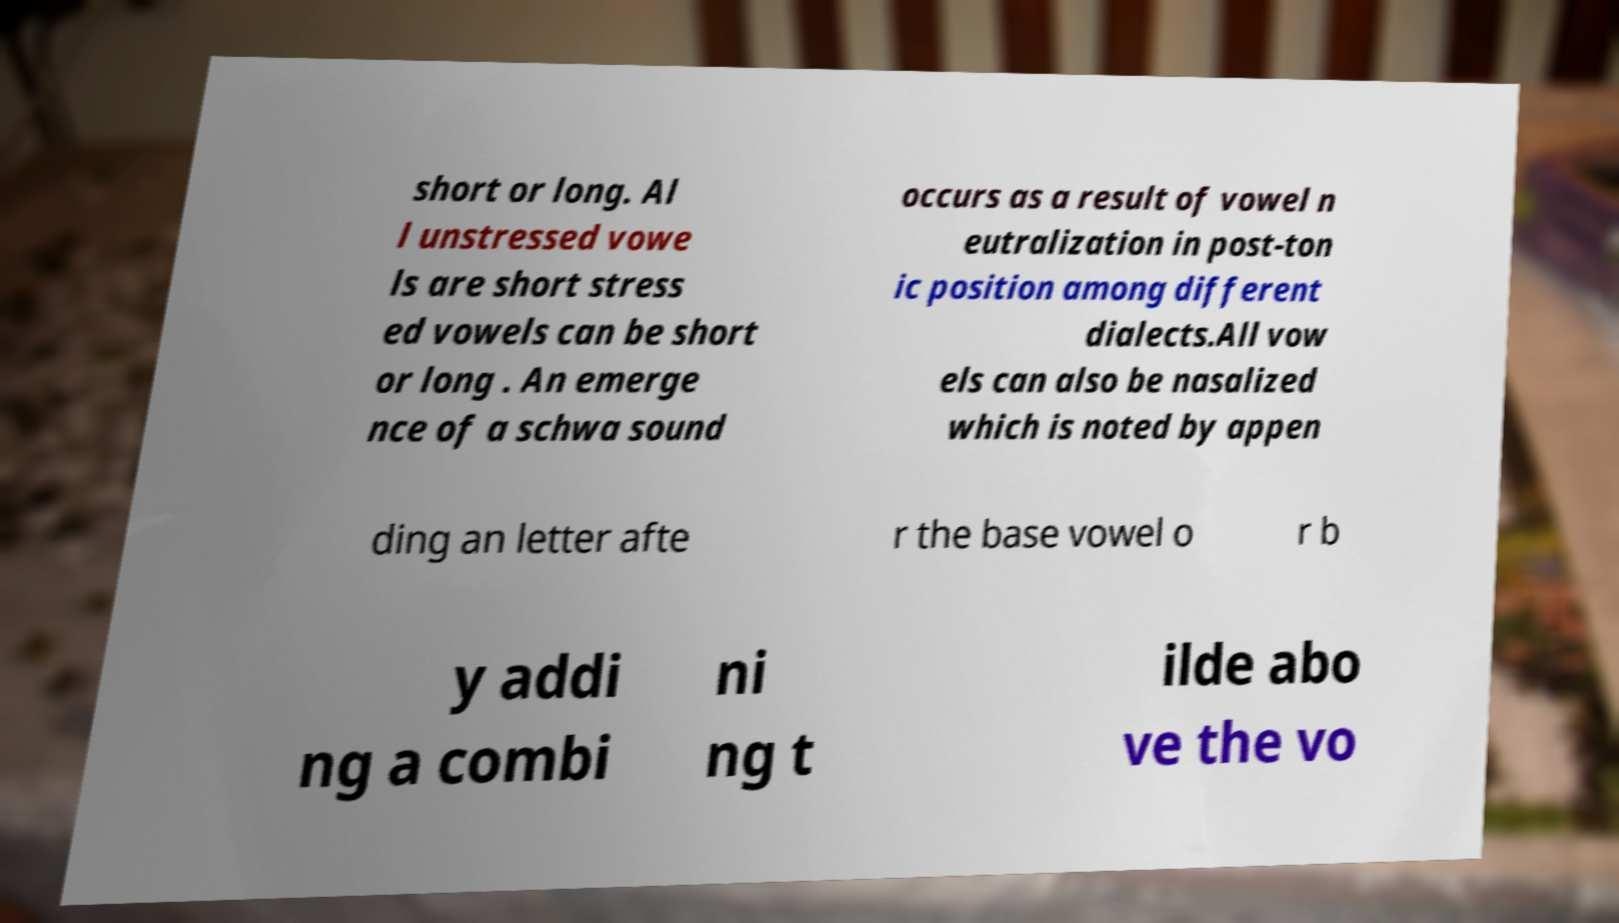I need the written content from this picture converted into text. Can you do that? short or long. Al l unstressed vowe ls are short stress ed vowels can be short or long . An emerge nce of a schwa sound occurs as a result of vowel n eutralization in post-ton ic position among different dialects.All vow els can also be nasalized which is noted by appen ding an letter afte r the base vowel o r b y addi ng a combi ni ng t ilde abo ve the vo 